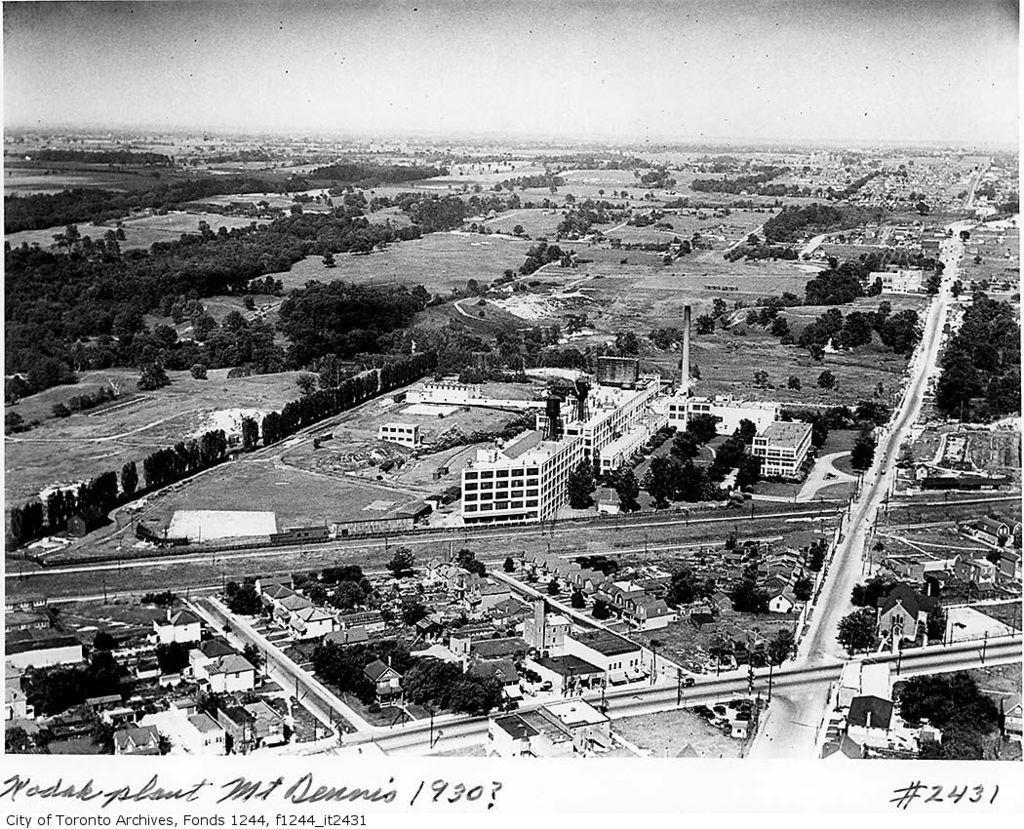Describe this image in one or two sentences. This is black and white aerial view where we can see buildings, trees, poles, roads and grassy lands. At the top of the image, we can see the sky. At the bottom of the image, there is a watermark. 